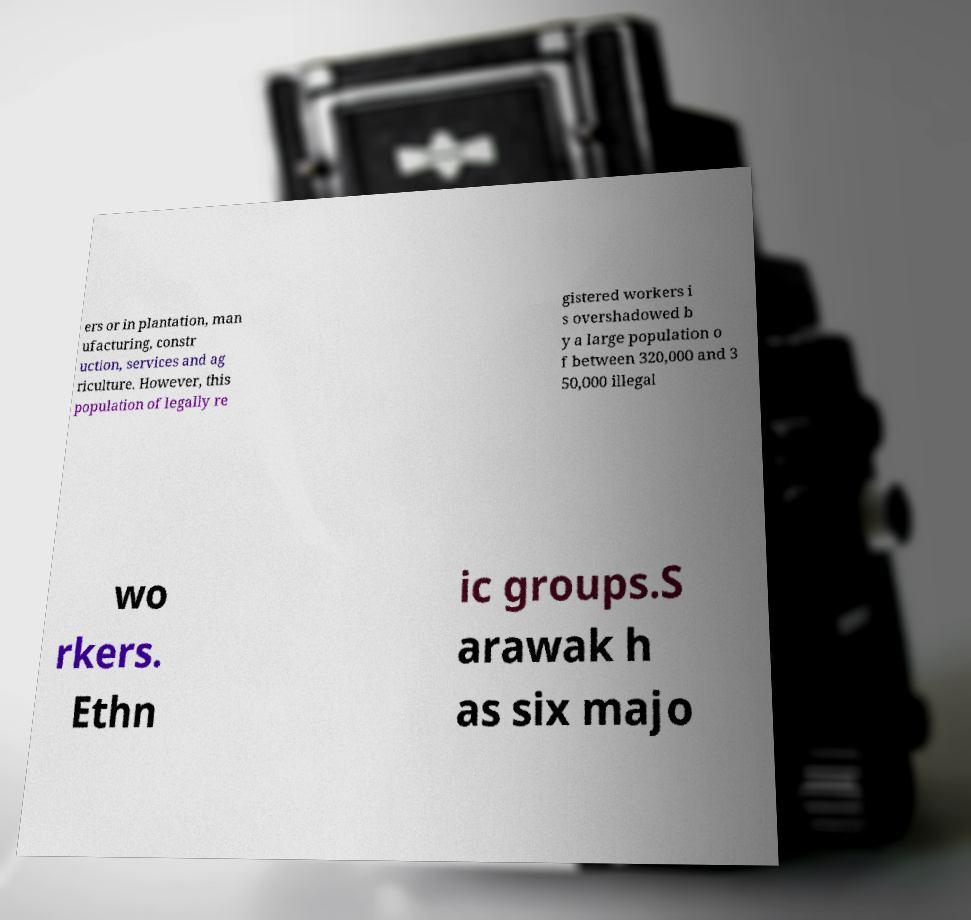I need the written content from this picture converted into text. Can you do that? ers or in plantation, man ufacturing, constr uction, services and ag riculture. However, this population of legally re gistered workers i s overshadowed b y a large population o f between 320,000 and 3 50,000 illegal wo rkers. Ethn ic groups.S arawak h as six majo 